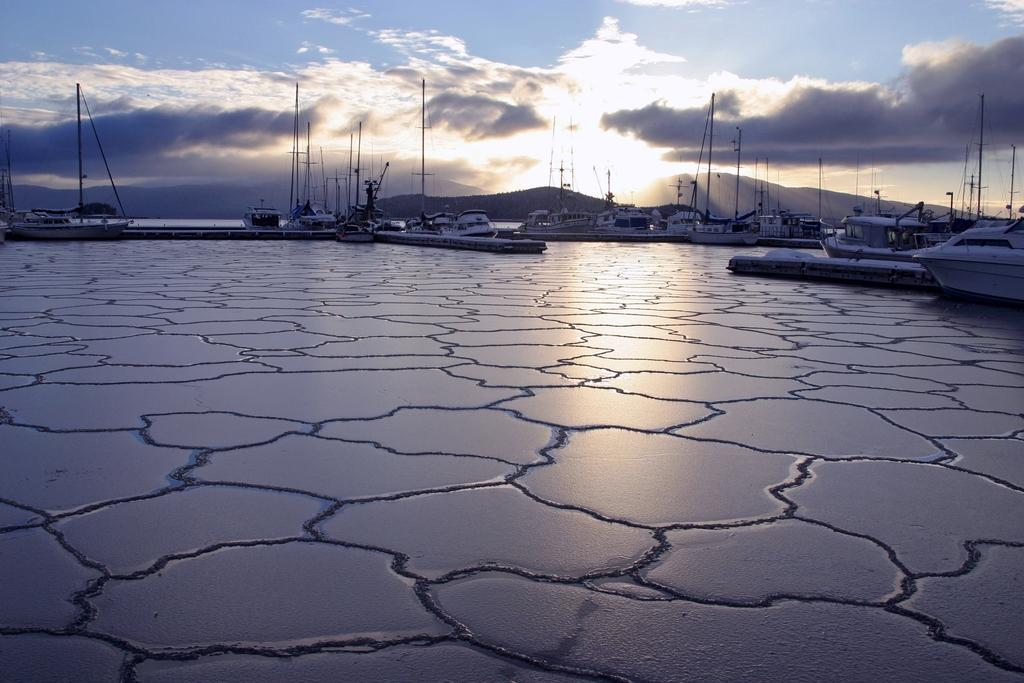What is located at the bottom of the image? There is ice at the bottom of the image. What is positioned above the ice? There are ships above the ice. What can be seen in the background of the image? There are hills visible in the background of the image. What is visible in the sky in the image? Clouds and the sun are visible in the sky. How many buttons can be seen on the lake in the image? There is no lake or buttons present in the image. What type of sorting activity is taking place in the image? There is no sorting activity present in the image. 